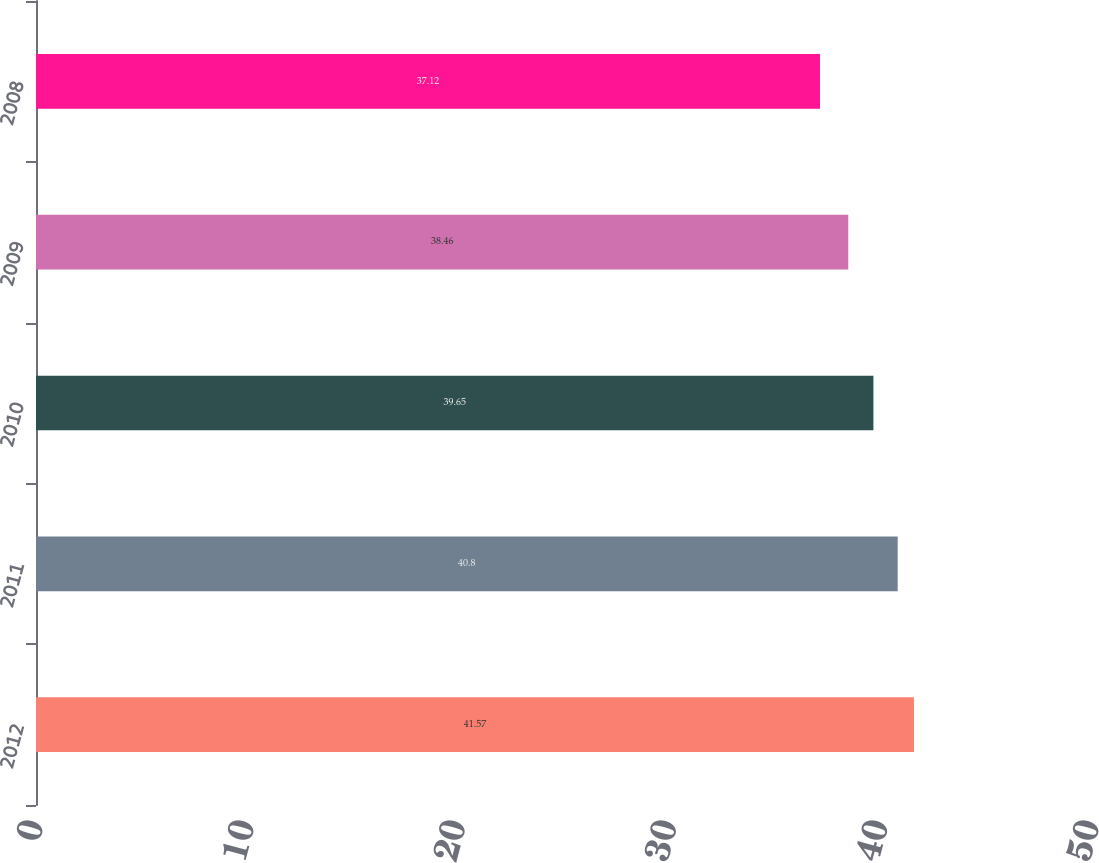Convert chart to OTSL. <chart><loc_0><loc_0><loc_500><loc_500><bar_chart><fcel>2012<fcel>2011<fcel>2010<fcel>2009<fcel>2008<nl><fcel>41.57<fcel>40.8<fcel>39.65<fcel>38.46<fcel>37.12<nl></chart> 